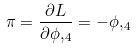Convert formula to latex. <formula><loc_0><loc_0><loc_500><loc_500>\pi = \frac { \partial L } { \partial \phi , _ { 4 } } = - \phi , _ { 4 }</formula> 